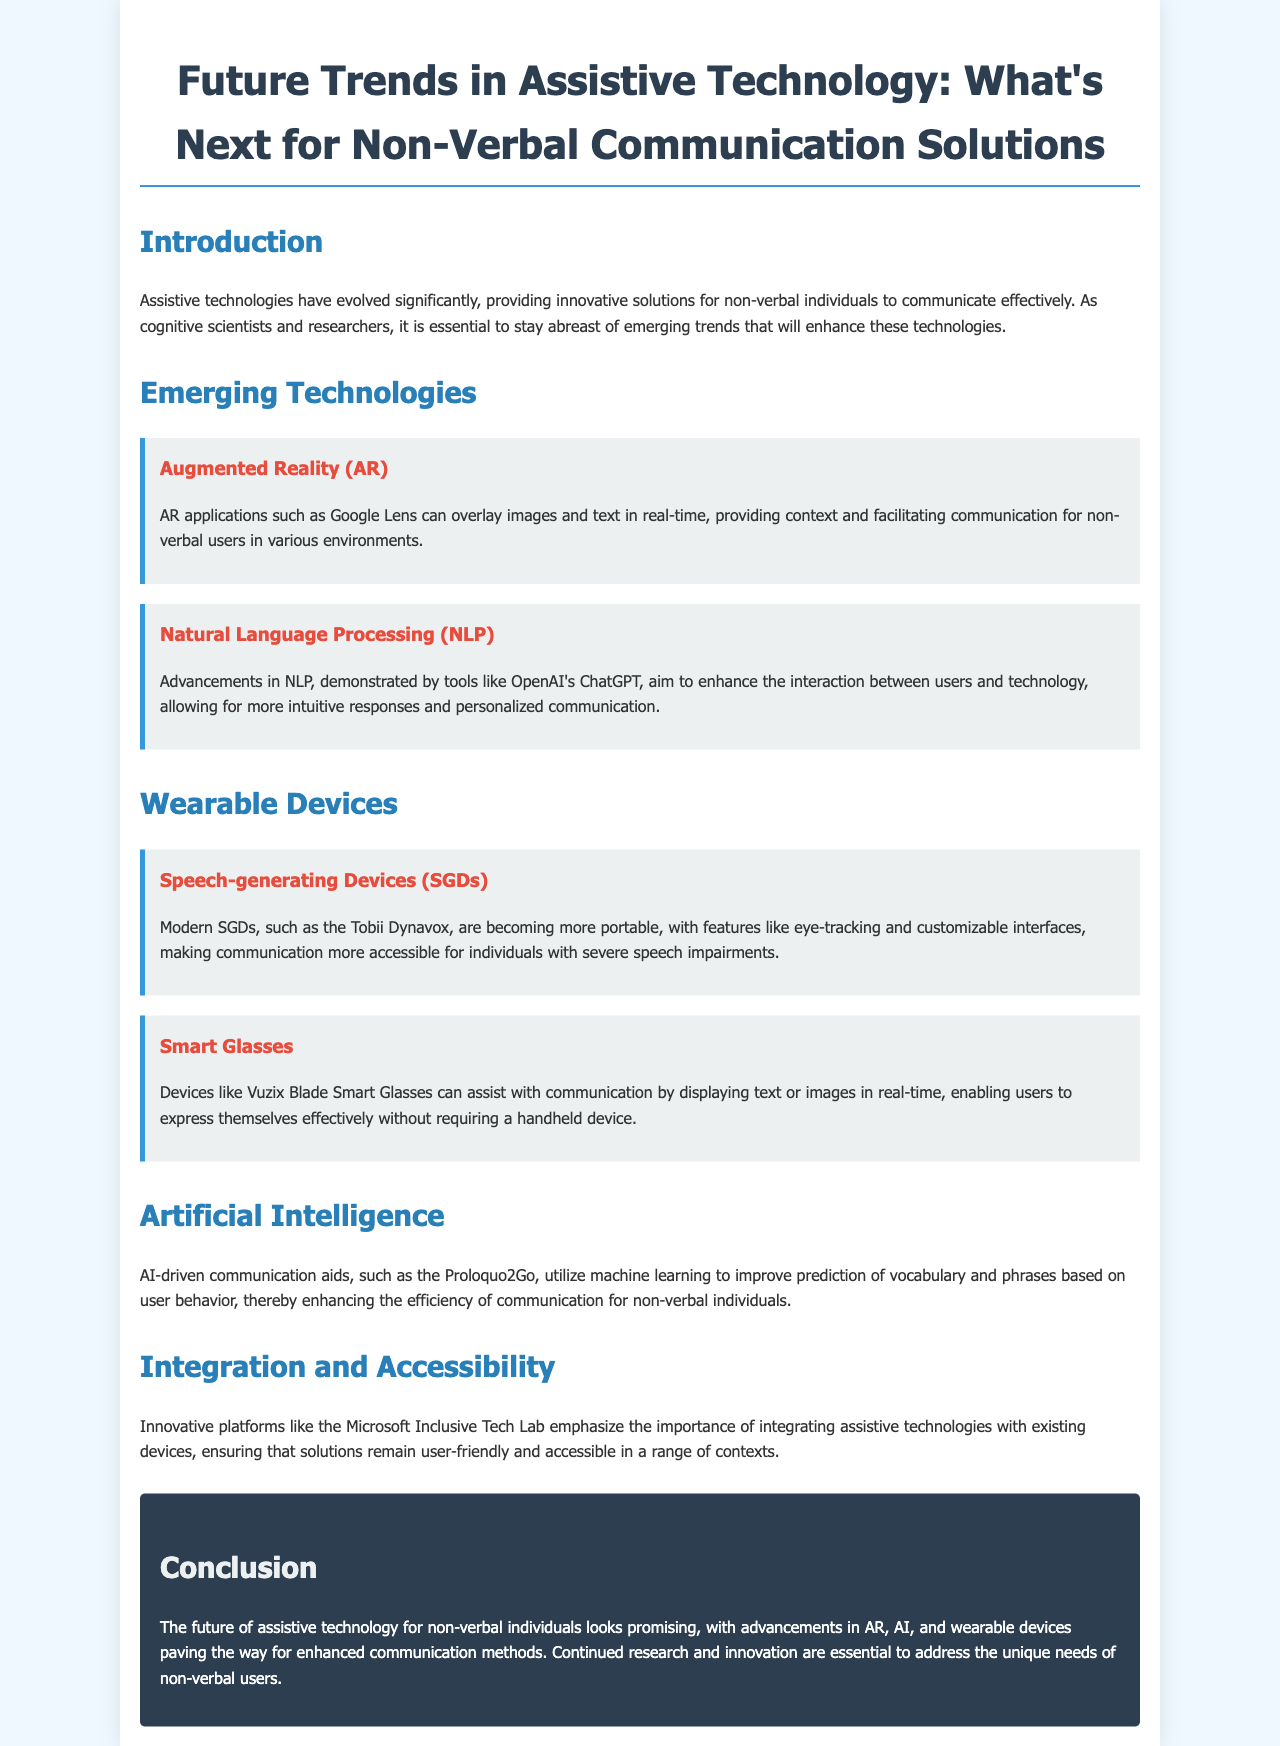What is the title of the document? The title is provided in the header section of the document, clearly stated as "Future Trends in Assistive Technology: What's Next for Non-Verbal Communication Solutions."
Answer: Future Trends in Assistive Technology: What's Next for Non-Verbal Communication Solutions What technology is mentioned as an AR application? The document presents Google Lens as an example of an AR application facilitating communication for non-verbal users.
Answer: Google Lens What type of device is the Tobii Dynavox? The document indicates that the Tobii Dynavox is a modern speech-generating device (SGD) intended for individuals with speech impairments.
Answer: speech-generating device (SGD) What is a key benefit of AI-driven communication aids like Proloquo2Go? The document highlights that these aids utilize machine learning to enhance the prediction of vocabulary and phrases based on user behavior.
Answer: improve prediction of vocabulary and phrases Which technology allows for real-time communication via images and text? The document states that augmented reality (AR) applications allow for communication through overlaying images and text in real-time.
Answer: Augmented Reality (AR) How does Microsoft Inclusive Tech Lab contribute to assistive technology? The document emphasizes that the Microsoft Inclusive Tech Lab focuses on integrating assistive technologies with existing devices to ensure accessibility and user-friendliness.
Answer: integrating assistive technologies What are smart glasses used for in communication? According to the document, smart glasses like Vuzix Blade assist with communication by displaying text or images in real-time for users.
Answer: displaying text or images in real-time What is the conclusion about the future of assistive technology for non-verbal individuals? The conclusion indicates that advancements in AR, AI, and wearable devices are paving the way for enhanced communication methods for non-verbal individuals.
Answer: promising What is the overall theme of the brochure? The document centers on exploring future trends in assistive technology specifically for non-verbal communication solutions.
Answer: future trends in assistive technology for non-verbal communication solutions 